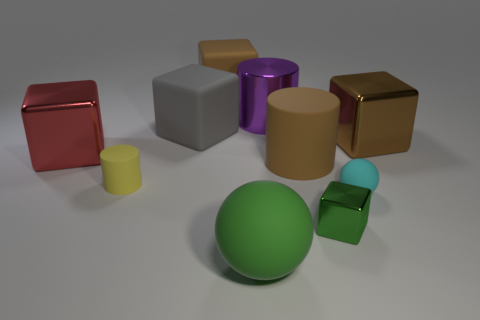What is the shape of the thing that is the same color as the large sphere?
Keep it short and to the point. Cube. There is a large brown object on the right side of the rubber cylinder that is on the right side of the gray rubber object; what number of large brown blocks are on the right side of it?
Provide a short and direct response. 0. What color is the metal cylinder that is the same size as the green sphere?
Make the answer very short. Purple. What number of other things are there of the same color as the big ball?
Keep it short and to the point. 1. Is the number of big shiny cubes that are right of the big matte sphere greater than the number of small cyan rubber cylinders?
Your answer should be compact. Yes. Does the tiny green block have the same material as the tiny yellow thing?
Your answer should be compact. No. What number of objects are either cubes to the left of the large rubber cylinder or small green shiny cubes?
Give a very brief answer. 4. What number of other things are there of the same size as the gray matte cube?
Your answer should be compact. 6. Are there an equal number of large brown things that are behind the big purple cylinder and large brown metallic blocks left of the cyan rubber object?
Your answer should be compact. No. What color is the other big metal object that is the same shape as the red object?
Your response must be concise. Brown. 